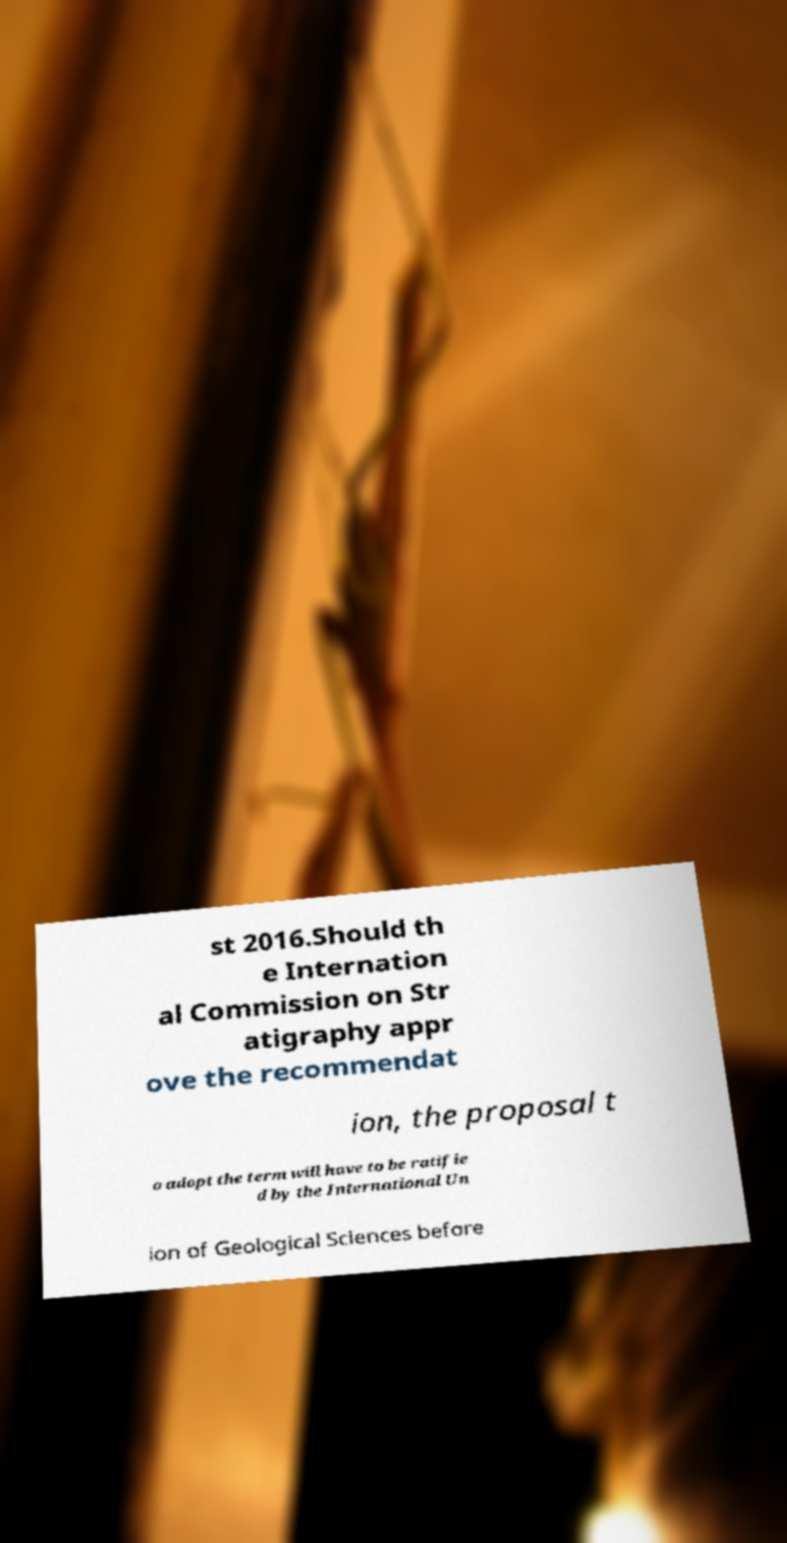Could you extract and type out the text from this image? st 2016.Should th e Internation al Commission on Str atigraphy appr ove the recommendat ion, the proposal t o adopt the term will have to be ratifie d by the International Un ion of Geological Sciences before 